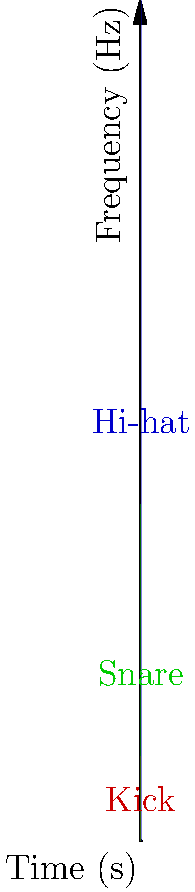As a drummer with a keen ear for indie music, examine the spectrogram showing the frequency content of three different drum sounds over time. Which drum typically has the highest frequency content and would likely cut through the mix in an indie rock song? To answer this question, let's analyze the spectrogram step-by-step:

1. The spectrogram shows three distinct drum sounds: kick, snare, and hi-hat.

2. The vertical axis represents frequency, with higher frequencies at the top.

3. The kick drum (in red) has the lowest frequency content, concentrated below 500 Hz.

4. The snare drum (in green) has a wider frequency range, reaching up to about 2000 Hz.

5. The hi-hat (in blue) has the highest frequency content, extending all the way up to 5000 Hz.

6. In indie rock music, cymbals and hi-hats often provide a crisp, cutting sound that helps define the rhythm and adds brightness to the overall mix.

7. The hi-hat's high-frequency content allows it to cut through even dense mixes, making it more audible than lower-frequency instruments.

Therefore, based on the spectrogram and typical characteristics of indie rock music, the hi-hat would likely cut through the mix most effectively due to its high-frequency content.
Answer: Hi-hat 